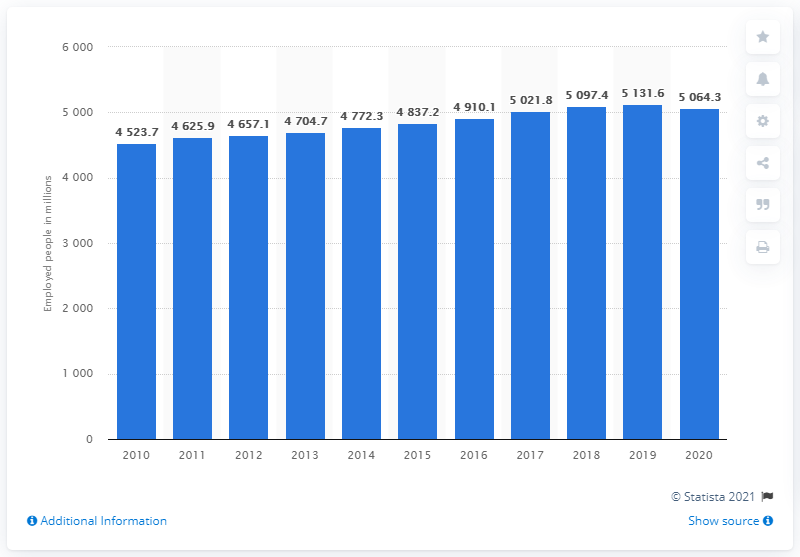Draw attention to some important aspects in this diagram. In 2010, there were 45,237 employed people in Sweden. In 2020, the number of people employed in Sweden was 45,237. 